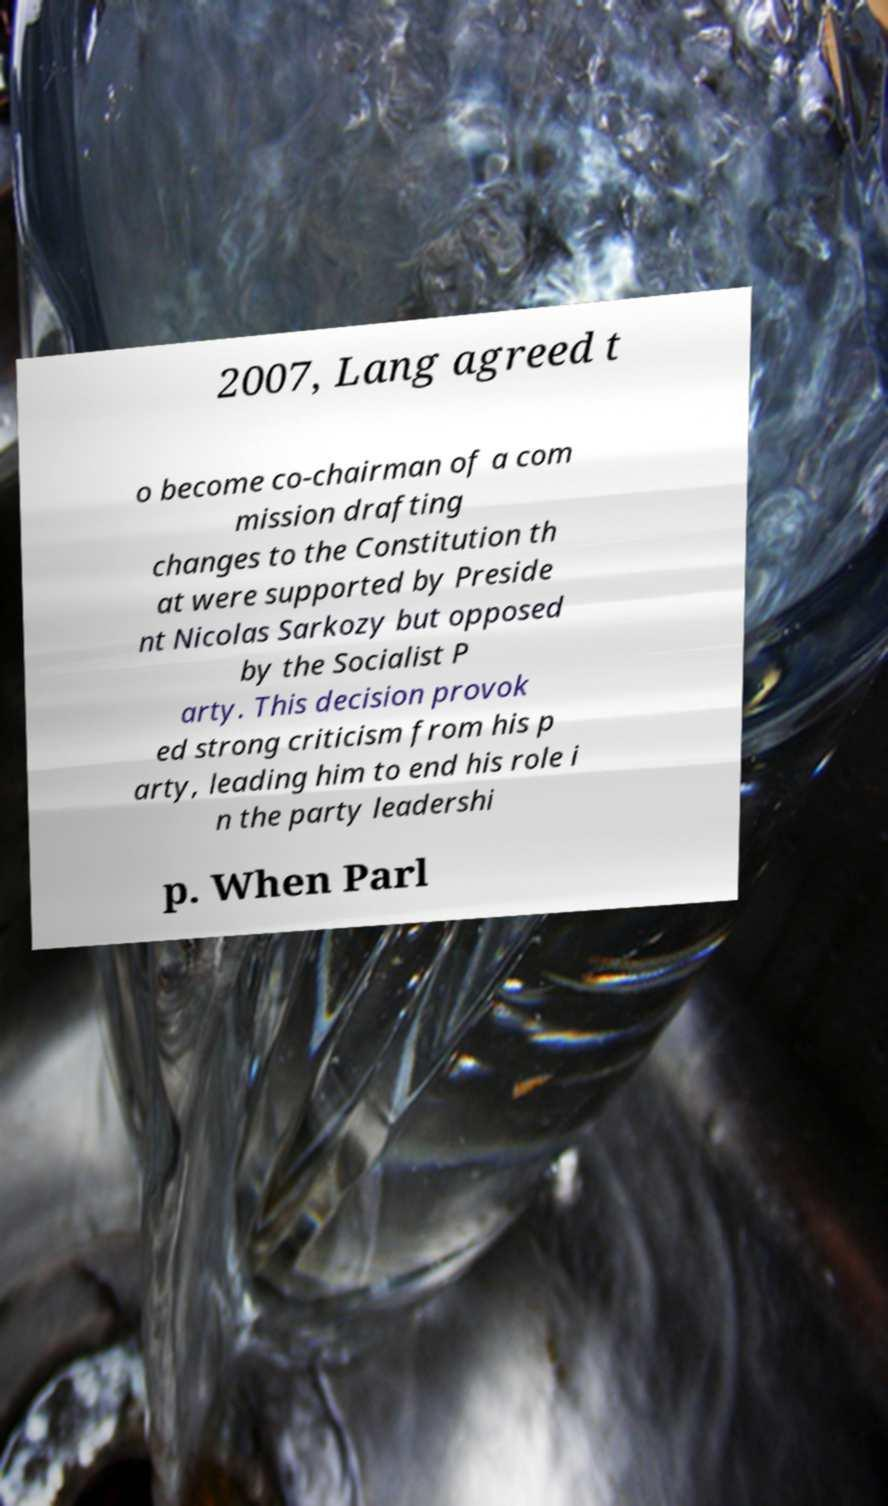I need the written content from this picture converted into text. Can you do that? 2007, Lang agreed t o become co-chairman of a com mission drafting changes to the Constitution th at were supported by Preside nt Nicolas Sarkozy but opposed by the Socialist P arty. This decision provok ed strong criticism from his p arty, leading him to end his role i n the party leadershi p. When Parl 